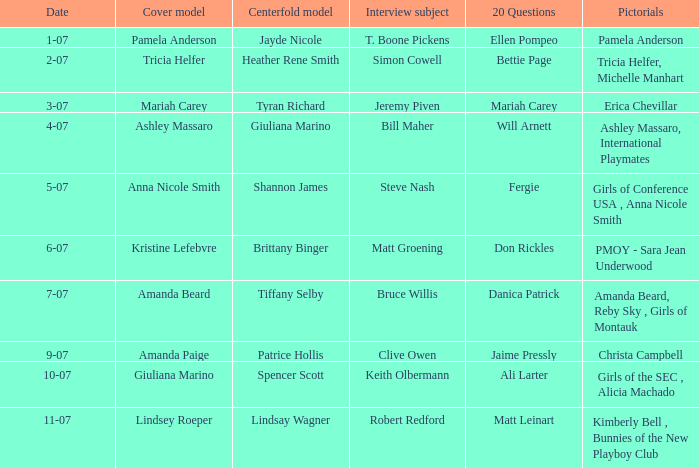Who was the centerfold model when the issue's pictorial was kimberly bell , bunnies of the new playboy club? Lindsay Wagner. 